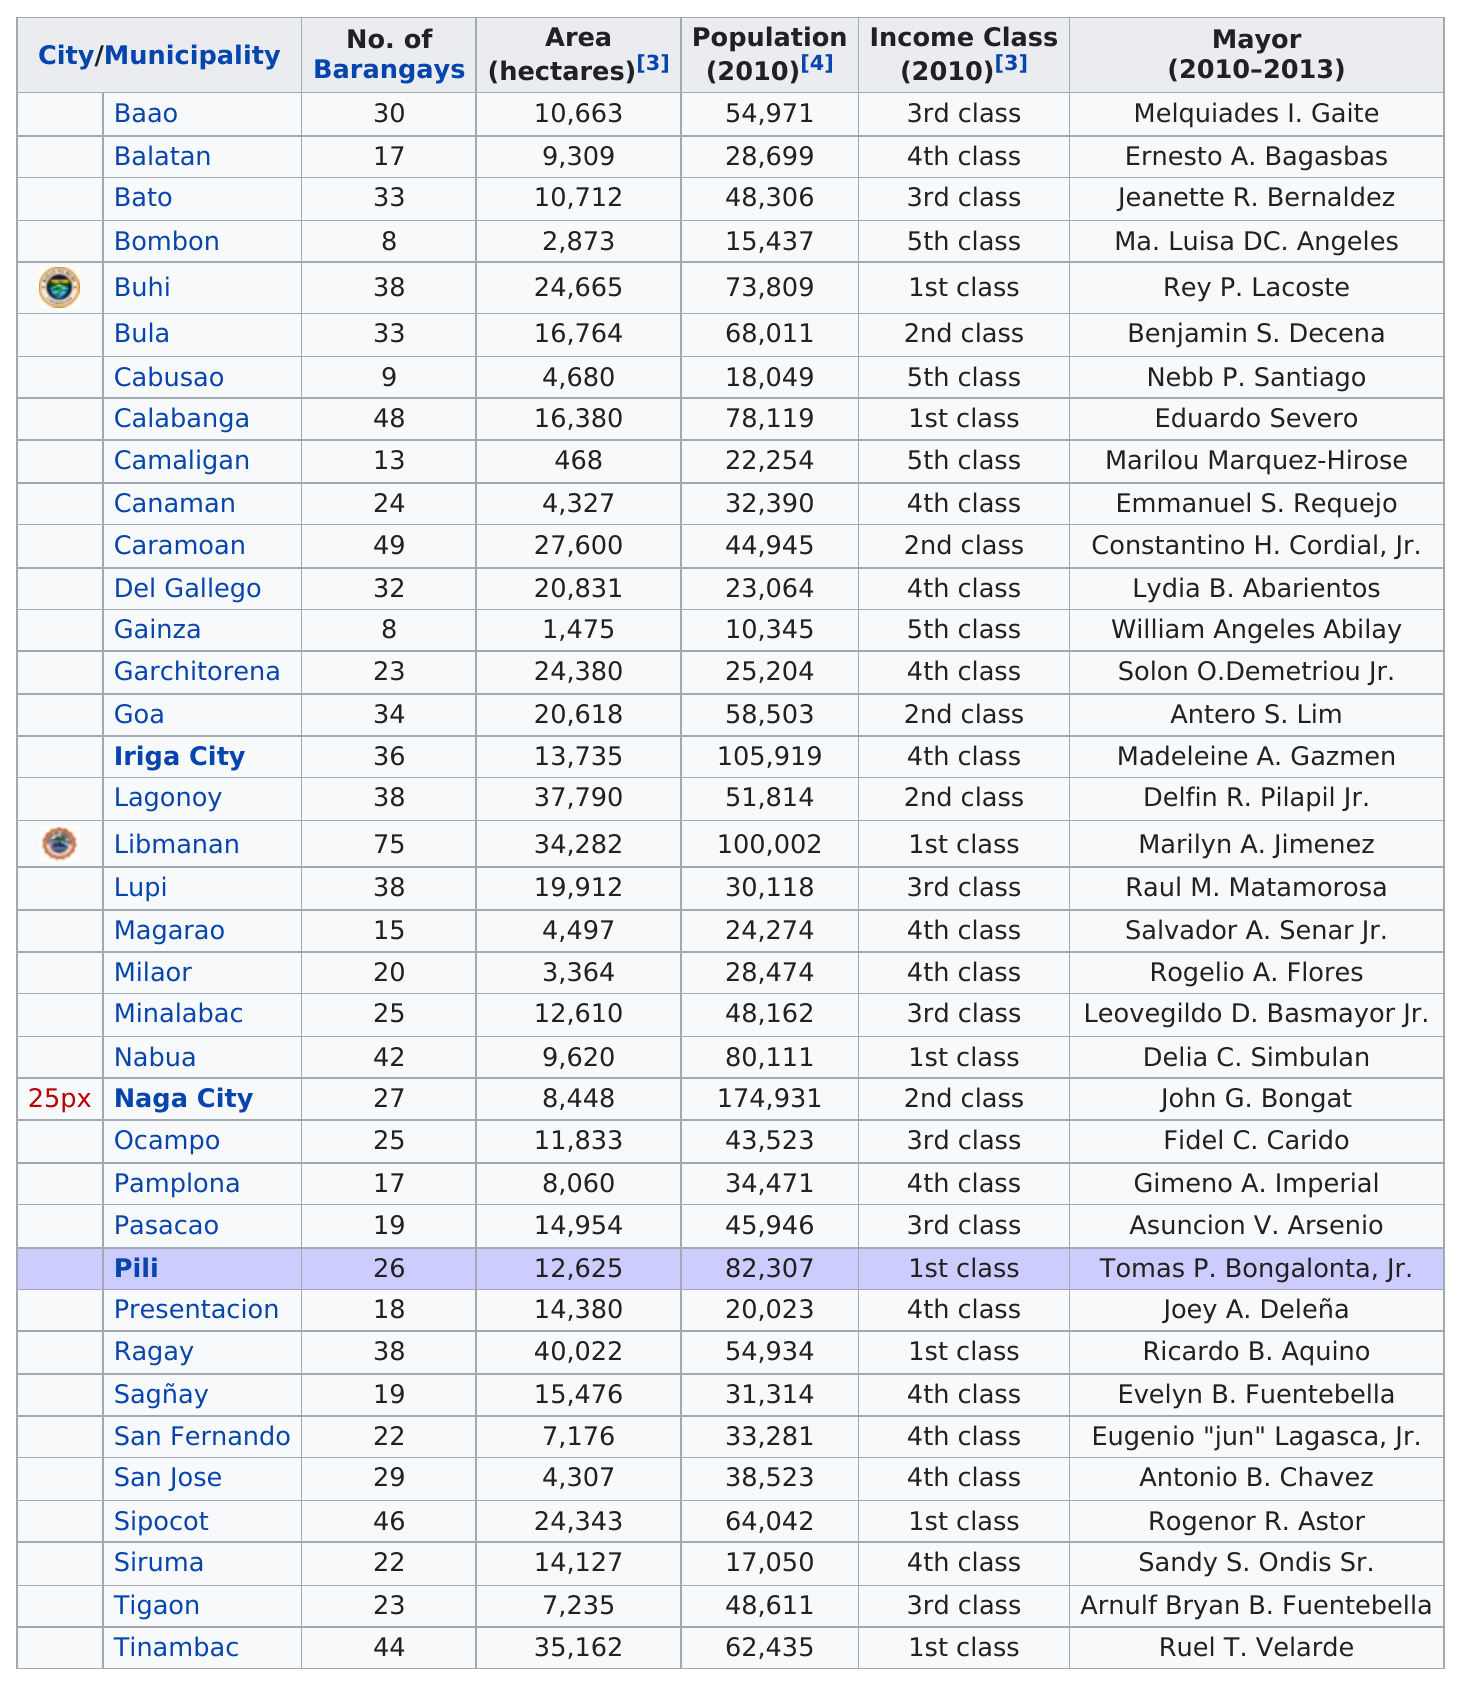Mention a couple of crucial points in this snapshot. The largest city/municipality in terms of area is Ragay. According to sources, Gainza is the least populated municipality in the province of Camarines Sur. In Camarines Sur, there are 35 municipalities. There are 37 total municipalities in Camarines Sur. Naga City is the most populous city in Camarines Sur. 